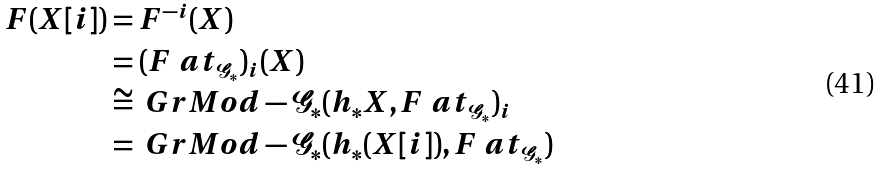Convert formula to latex. <formula><loc_0><loc_0><loc_500><loc_500>F ( X [ i ] ) & = F ^ { - i } ( X ) \\ & = ( F \ a t _ { \mathcal { G } _ { * } } ) _ { i } ( X ) \\ & \cong \ G r M o d - \mathcal { G } _ { * } ( h _ { * } X , F \ a t _ { \mathcal { G } _ { * } } ) _ { i } \\ & = \ G r M o d - \mathcal { G } _ { * } ( h _ { * } ( X [ i ] ) , F \ a t _ { \mathcal { G } _ { * } } )</formula> 